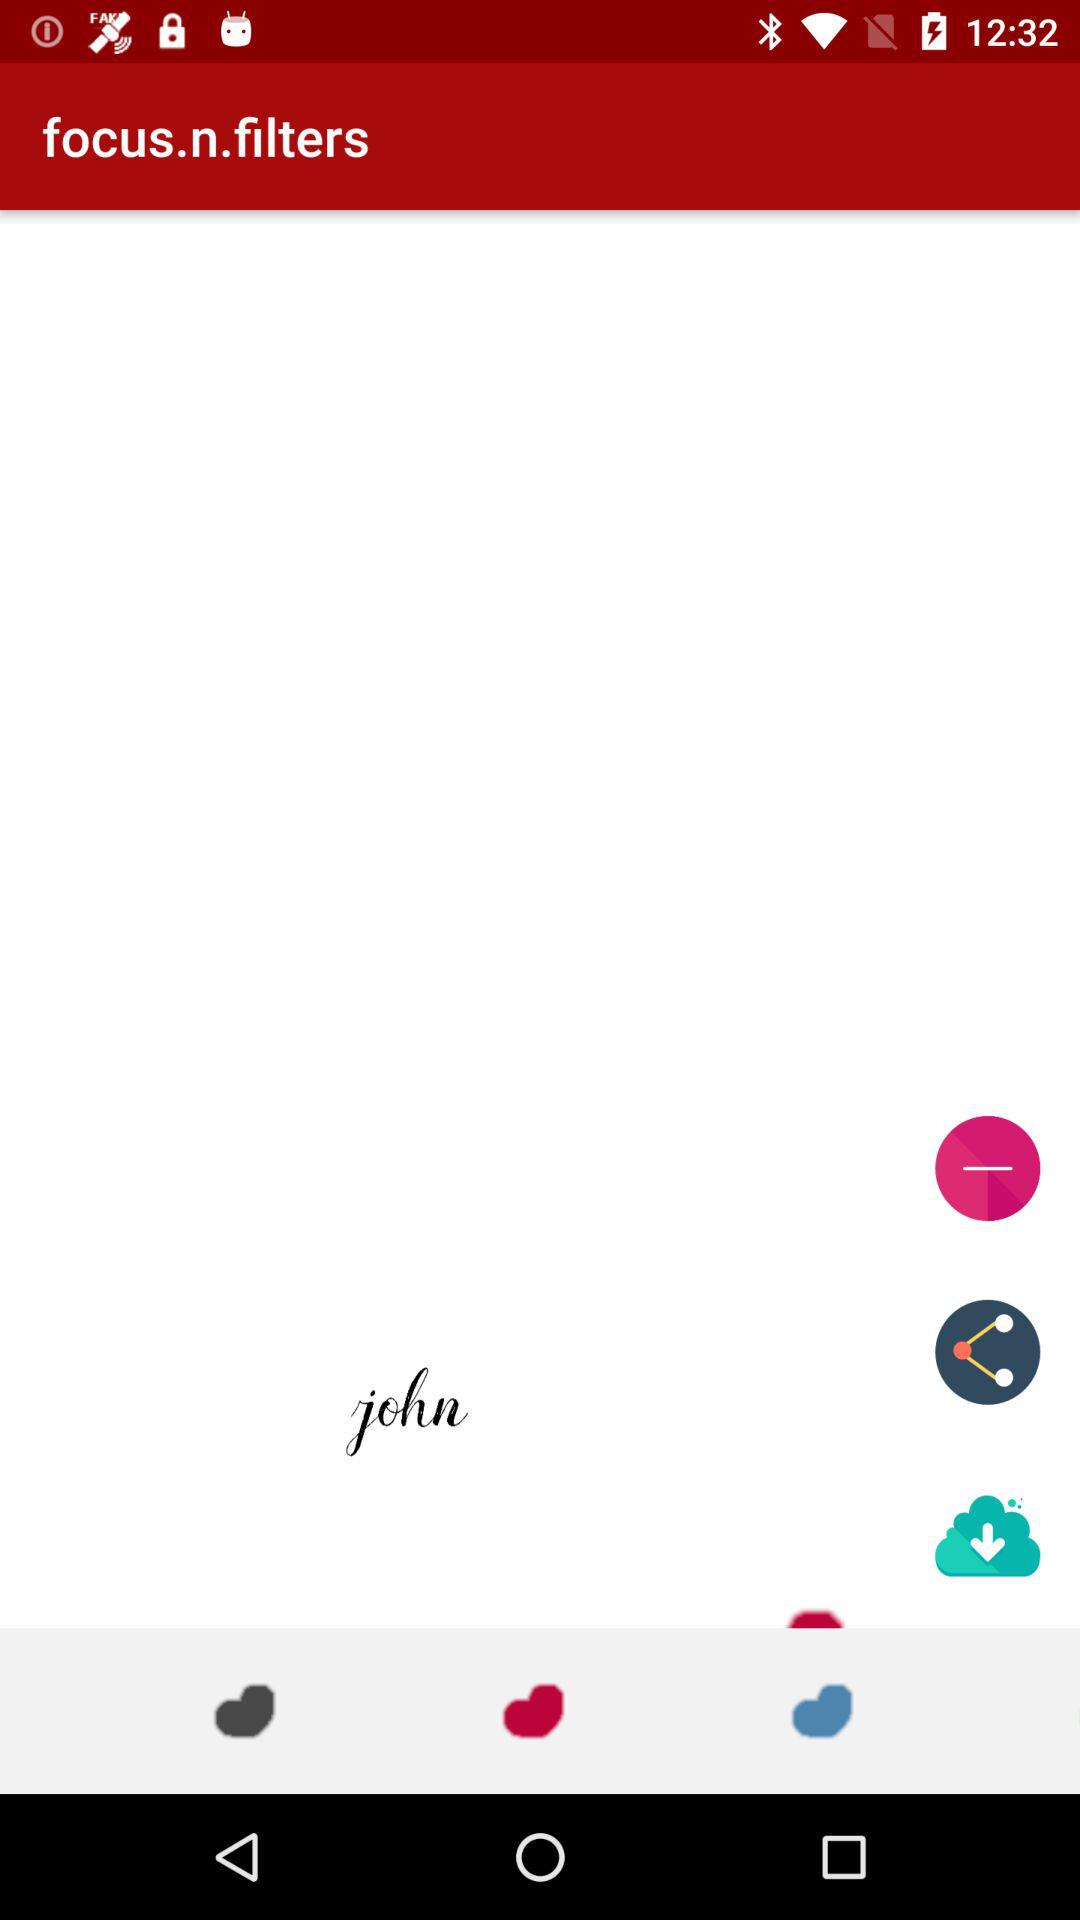How many hearts are there?
Answer the question using a single word or phrase. 3 